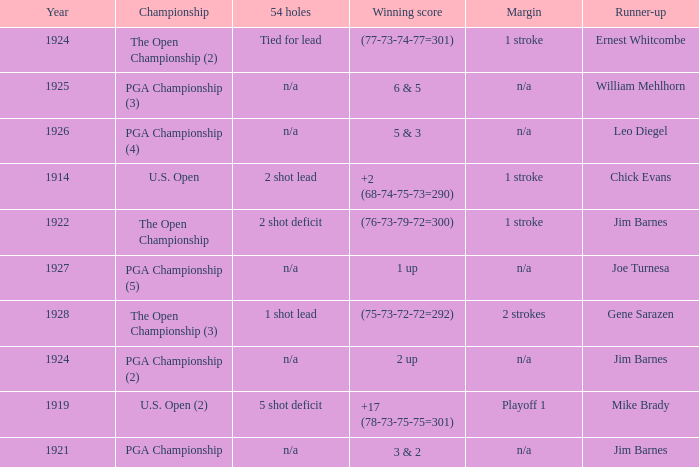WHAT YEAR WAS IT WHEN THE SCORE WAS 3 & 2? 1921.0. 